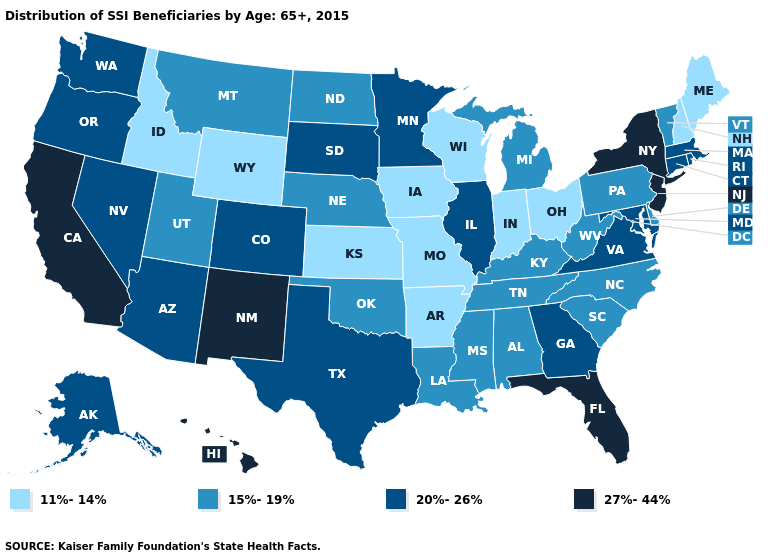Does the first symbol in the legend represent the smallest category?
Answer briefly. Yes. What is the value of Idaho?
Answer briefly. 11%-14%. What is the value of Alaska?
Be succinct. 20%-26%. Name the states that have a value in the range 27%-44%?
Answer briefly. California, Florida, Hawaii, New Jersey, New Mexico, New York. What is the highest value in the MidWest ?
Write a very short answer. 20%-26%. Does Mississippi have the lowest value in the South?
Be succinct. No. What is the lowest value in the MidWest?
Quick response, please. 11%-14%. Does Missouri have the lowest value in the USA?
Quick response, please. Yes. Does the first symbol in the legend represent the smallest category?
Keep it brief. Yes. What is the value of Iowa?
Keep it brief. 11%-14%. What is the value of Tennessee?
Quick response, please. 15%-19%. What is the value of Nevada?
Short answer required. 20%-26%. What is the value of Alabama?
Keep it brief. 15%-19%. Does Mississippi have the same value as Hawaii?
Concise answer only. No. What is the value of New Mexico?
Concise answer only. 27%-44%. 